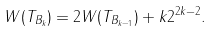Convert formula to latex. <formula><loc_0><loc_0><loc_500><loc_500>W ( T _ { B _ { k } } ) = 2 W ( T _ { B _ { k - 1 } } ) + k 2 ^ { 2 k - 2 } .</formula> 